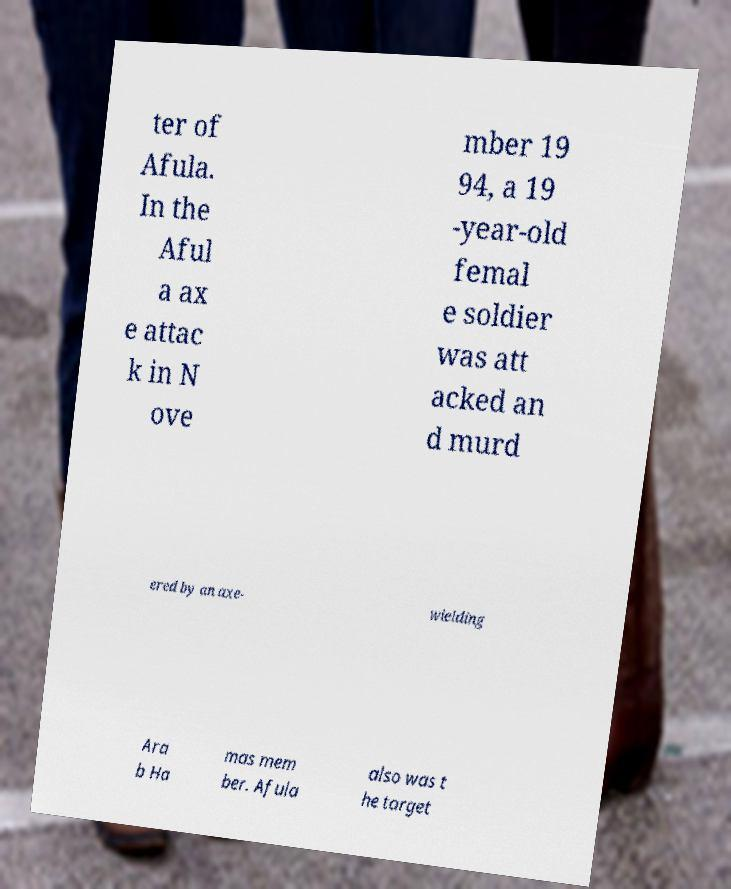Please read and relay the text visible in this image. What does it say? ter of Afula. In the Aful a ax e attac k in N ove mber 19 94, a 19 -year-old femal e soldier was att acked an d murd ered by an axe- wielding Ara b Ha mas mem ber. Afula also was t he target 